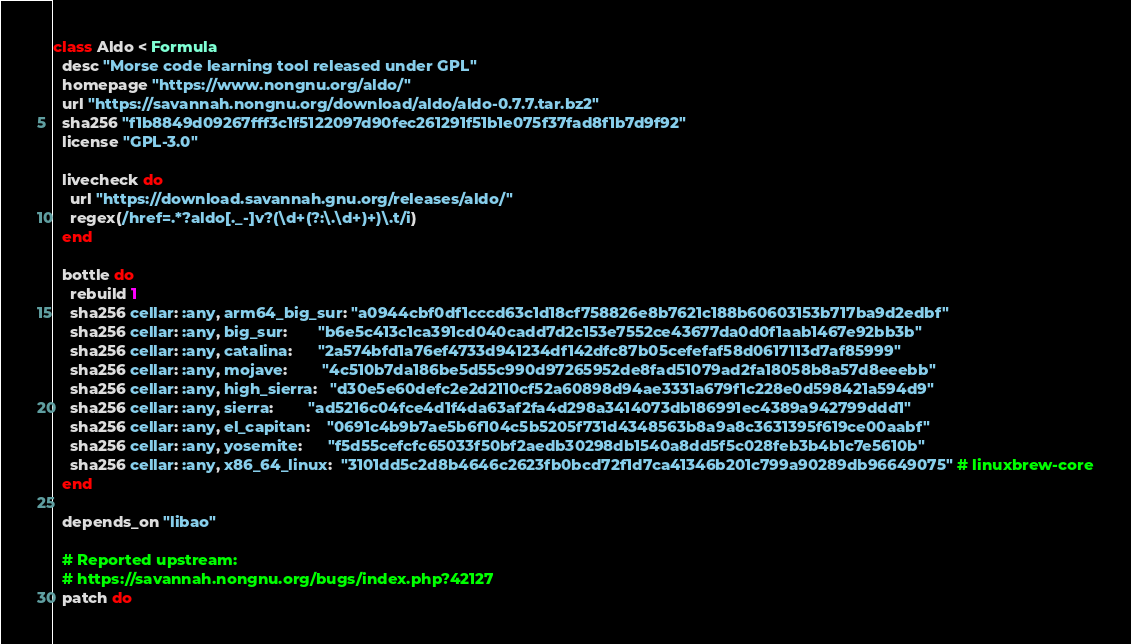Convert code to text. <code><loc_0><loc_0><loc_500><loc_500><_Ruby_>class Aldo < Formula
  desc "Morse code learning tool released under GPL"
  homepage "https://www.nongnu.org/aldo/"
  url "https://savannah.nongnu.org/download/aldo/aldo-0.7.7.tar.bz2"
  sha256 "f1b8849d09267fff3c1f5122097d90fec261291f51b1e075f37fad8f1b7d9f92"
  license "GPL-3.0"

  livecheck do
    url "https://download.savannah.gnu.org/releases/aldo/"
    regex(/href=.*?aldo[._-]v?(\d+(?:\.\d+)+)\.t/i)
  end

  bottle do
    rebuild 1
    sha256 cellar: :any, arm64_big_sur: "a0944cbf0df1cccd63c1d18cf758826e8b7621c188b60603153b717ba9d2edbf"
    sha256 cellar: :any, big_sur:       "b6e5c413c1ca391cd040cadd7d2c153e7552ce43677da0d0f1aab1467e92bb3b"
    sha256 cellar: :any, catalina:      "2a574bfd1a76ef4733d941234df142dfc87b05cefefaf58d0617113d7af85999"
    sha256 cellar: :any, mojave:        "4c510b7da186be5d55c990d97265952de8fad51079ad2fa18058b8a57d8eeebb"
    sha256 cellar: :any, high_sierra:   "d30e5e60defc2e2d2110cf52a60898d94ae3331a679f1c228e0d598421a594d9"
    sha256 cellar: :any, sierra:        "ad5216c04fce4d1f4da63af2fa4d298a3414073db186991ec4389a942799ddd1"
    sha256 cellar: :any, el_capitan:    "0691c4b9b7ae5b6f104c5b5205f731d4348563b8a9a8c3631395f619ce00aabf"
    sha256 cellar: :any, yosemite:      "f5d55cefcfc65033f50bf2aedb30298db1540a8dd5f5c028feb3b4b1c7e5610b"
    sha256 cellar: :any, x86_64_linux:  "3101dd5c2d8b4646c2623fb0bcd72f1d7ca41346b201c799a90289db96649075" # linuxbrew-core
  end

  depends_on "libao"

  # Reported upstream:
  # https://savannah.nongnu.org/bugs/index.php?42127
  patch do</code> 